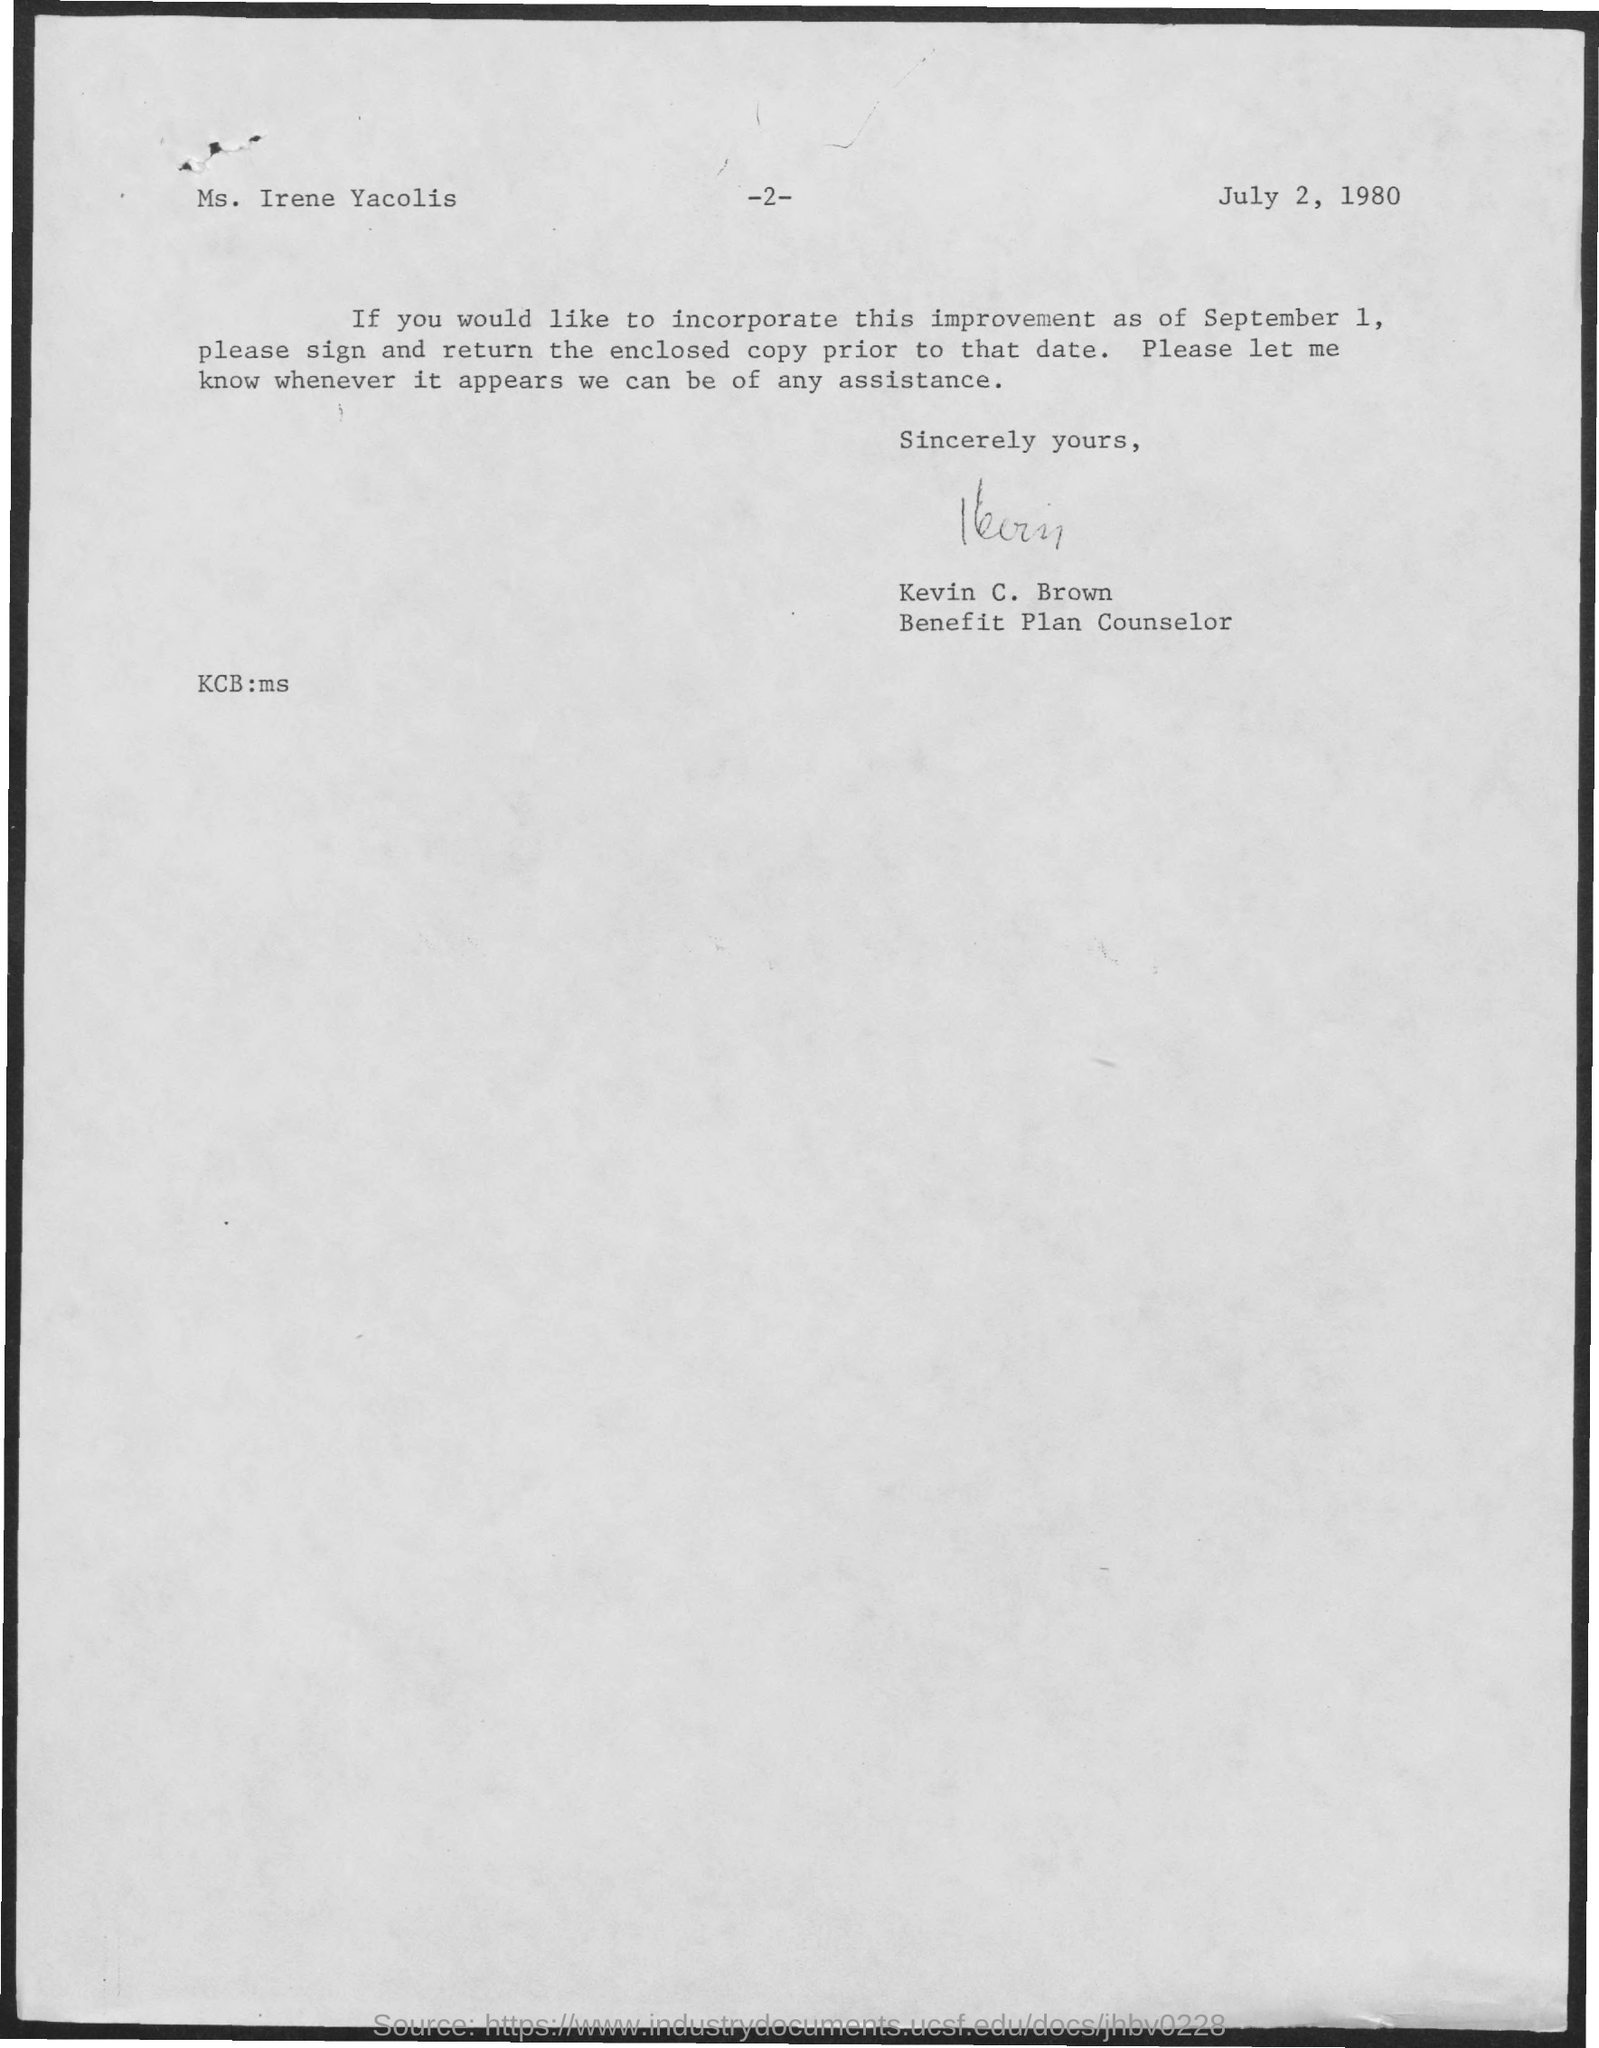Draw attention to some important aspects in this diagram. The date on the document is July 2, 1980. The letter is from Kevin C. Brown. The letter is addressed to Ms. Irene Yacolis. 